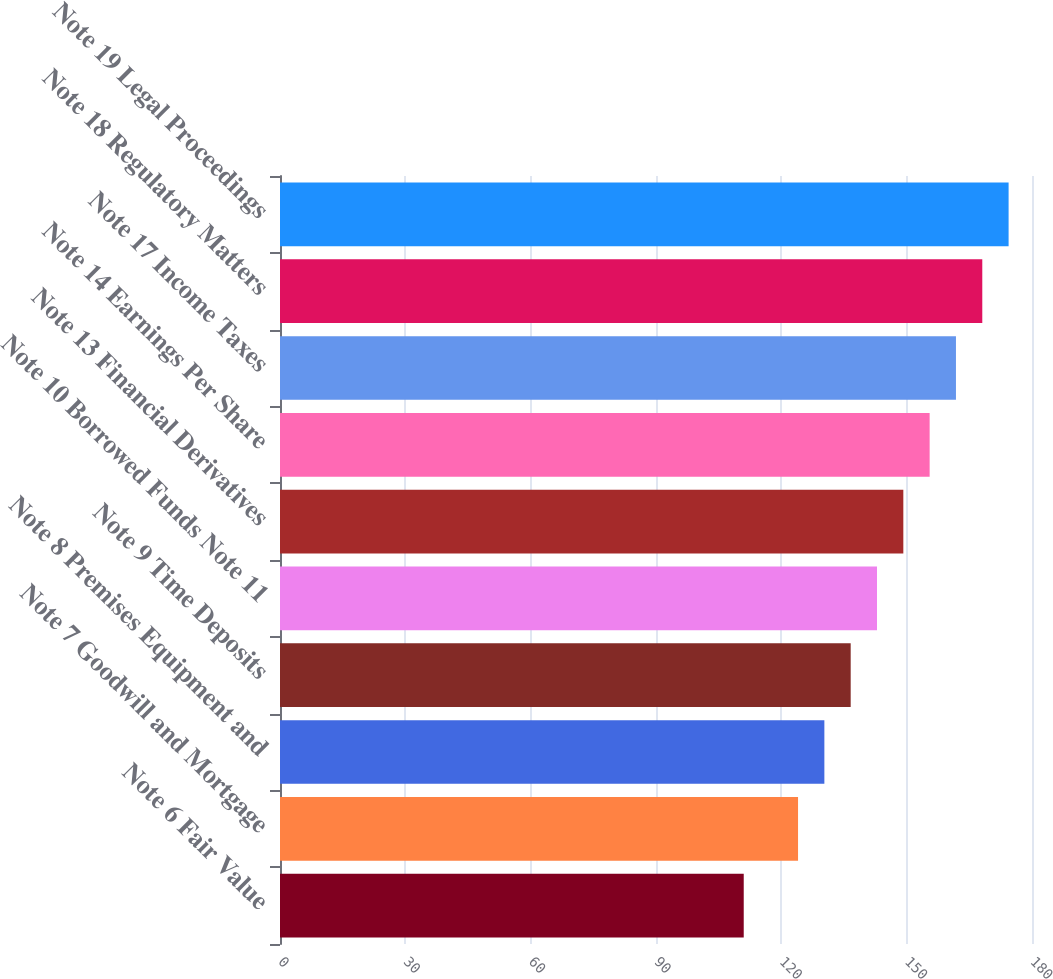<chart> <loc_0><loc_0><loc_500><loc_500><bar_chart><fcel>Note 6 Fair Value<fcel>Note 7 Goodwill and Mortgage<fcel>Note 8 Premises Equipment and<fcel>Note 9 Time Deposits<fcel>Note 10 Borrowed Funds Note 11<fcel>Note 13 Financial Derivatives<fcel>Note 14 Earnings Per Share<fcel>Note 17 Income Taxes<fcel>Note 18 Regulatory Matters<fcel>Note 19 Legal Proceedings<nl><fcel>111<fcel>124<fcel>130.3<fcel>136.6<fcel>142.9<fcel>149.2<fcel>155.5<fcel>161.8<fcel>168.1<fcel>174.4<nl></chart> 